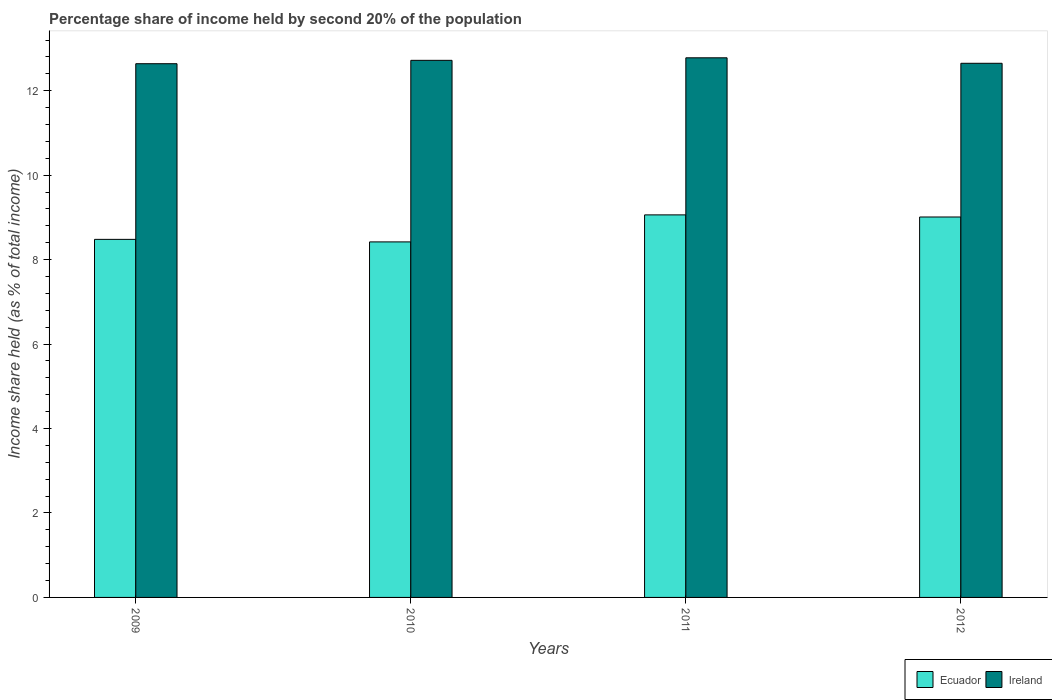How many groups of bars are there?
Provide a short and direct response. 4. Are the number of bars per tick equal to the number of legend labels?
Provide a succinct answer. Yes. How many bars are there on the 2nd tick from the left?
Your answer should be compact. 2. What is the label of the 4th group of bars from the left?
Make the answer very short. 2012. In how many cases, is the number of bars for a given year not equal to the number of legend labels?
Provide a succinct answer. 0. What is the share of income held by second 20% of the population in Ecuador in 2011?
Offer a very short reply. 9.06. Across all years, what is the maximum share of income held by second 20% of the population in Ireland?
Offer a terse response. 12.78. Across all years, what is the minimum share of income held by second 20% of the population in Ecuador?
Offer a terse response. 8.42. What is the total share of income held by second 20% of the population in Ecuador in the graph?
Make the answer very short. 34.97. What is the difference between the share of income held by second 20% of the population in Ecuador in 2010 and that in 2011?
Your answer should be compact. -0.64. What is the difference between the share of income held by second 20% of the population in Ecuador in 2010 and the share of income held by second 20% of the population in Ireland in 2009?
Provide a short and direct response. -4.22. What is the average share of income held by second 20% of the population in Ireland per year?
Your response must be concise. 12.7. In the year 2010, what is the difference between the share of income held by second 20% of the population in Ireland and share of income held by second 20% of the population in Ecuador?
Make the answer very short. 4.3. What is the ratio of the share of income held by second 20% of the population in Ireland in 2009 to that in 2011?
Your response must be concise. 0.99. Is the share of income held by second 20% of the population in Ecuador in 2010 less than that in 2012?
Offer a very short reply. Yes. Is the difference between the share of income held by second 20% of the population in Ireland in 2009 and 2010 greater than the difference between the share of income held by second 20% of the population in Ecuador in 2009 and 2010?
Provide a succinct answer. No. What is the difference between the highest and the second highest share of income held by second 20% of the population in Ecuador?
Give a very brief answer. 0.05. What is the difference between the highest and the lowest share of income held by second 20% of the population in Ireland?
Make the answer very short. 0.14. What does the 1st bar from the left in 2012 represents?
Your answer should be very brief. Ecuador. What does the 1st bar from the right in 2010 represents?
Your response must be concise. Ireland. How many bars are there?
Provide a succinct answer. 8. Where does the legend appear in the graph?
Provide a short and direct response. Bottom right. How many legend labels are there?
Offer a very short reply. 2. How are the legend labels stacked?
Make the answer very short. Horizontal. What is the title of the graph?
Provide a short and direct response. Percentage share of income held by second 20% of the population. What is the label or title of the Y-axis?
Your answer should be compact. Income share held (as % of total income). What is the Income share held (as % of total income) of Ecuador in 2009?
Provide a short and direct response. 8.48. What is the Income share held (as % of total income) of Ireland in 2009?
Give a very brief answer. 12.64. What is the Income share held (as % of total income) of Ecuador in 2010?
Your answer should be compact. 8.42. What is the Income share held (as % of total income) of Ireland in 2010?
Provide a short and direct response. 12.72. What is the Income share held (as % of total income) of Ecuador in 2011?
Your answer should be very brief. 9.06. What is the Income share held (as % of total income) of Ireland in 2011?
Provide a short and direct response. 12.78. What is the Income share held (as % of total income) of Ecuador in 2012?
Your answer should be compact. 9.01. What is the Income share held (as % of total income) of Ireland in 2012?
Your answer should be very brief. 12.65. Across all years, what is the maximum Income share held (as % of total income) in Ecuador?
Give a very brief answer. 9.06. Across all years, what is the maximum Income share held (as % of total income) in Ireland?
Your answer should be compact. 12.78. Across all years, what is the minimum Income share held (as % of total income) in Ecuador?
Give a very brief answer. 8.42. Across all years, what is the minimum Income share held (as % of total income) of Ireland?
Make the answer very short. 12.64. What is the total Income share held (as % of total income) in Ecuador in the graph?
Make the answer very short. 34.97. What is the total Income share held (as % of total income) of Ireland in the graph?
Your answer should be compact. 50.79. What is the difference between the Income share held (as % of total income) in Ecuador in 2009 and that in 2010?
Provide a succinct answer. 0.06. What is the difference between the Income share held (as % of total income) in Ireland in 2009 and that in 2010?
Give a very brief answer. -0.08. What is the difference between the Income share held (as % of total income) in Ecuador in 2009 and that in 2011?
Ensure brevity in your answer.  -0.58. What is the difference between the Income share held (as % of total income) of Ireland in 2009 and that in 2011?
Offer a terse response. -0.14. What is the difference between the Income share held (as % of total income) in Ecuador in 2009 and that in 2012?
Your response must be concise. -0.53. What is the difference between the Income share held (as % of total income) in Ireland in 2009 and that in 2012?
Offer a very short reply. -0.01. What is the difference between the Income share held (as % of total income) of Ecuador in 2010 and that in 2011?
Keep it short and to the point. -0.64. What is the difference between the Income share held (as % of total income) in Ireland in 2010 and that in 2011?
Offer a very short reply. -0.06. What is the difference between the Income share held (as % of total income) of Ecuador in 2010 and that in 2012?
Provide a short and direct response. -0.59. What is the difference between the Income share held (as % of total income) of Ireland in 2010 and that in 2012?
Your response must be concise. 0.07. What is the difference between the Income share held (as % of total income) in Ireland in 2011 and that in 2012?
Offer a very short reply. 0.13. What is the difference between the Income share held (as % of total income) in Ecuador in 2009 and the Income share held (as % of total income) in Ireland in 2010?
Give a very brief answer. -4.24. What is the difference between the Income share held (as % of total income) in Ecuador in 2009 and the Income share held (as % of total income) in Ireland in 2011?
Keep it short and to the point. -4.3. What is the difference between the Income share held (as % of total income) of Ecuador in 2009 and the Income share held (as % of total income) of Ireland in 2012?
Offer a very short reply. -4.17. What is the difference between the Income share held (as % of total income) in Ecuador in 2010 and the Income share held (as % of total income) in Ireland in 2011?
Offer a very short reply. -4.36. What is the difference between the Income share held (as % of total income) in Ecuador in 2010 and the Income share held (as % of total income) in Ireland in 2012?
Your answer should be compact. -4.23. What is the difference between the Income share held (as % of total income) in Ecuador in 2011 and the Income share held (as % of total income) in Ireland in 2012?
Provide a short and direct response. -3.59. What is the average Income share held (as % of total income) of Ecuador per year?
Make the answer very short. 8.74. What is the average Income share held (as % of total income) of Ireland per year?
Offer a terse response. 12.7. In the year 2009, what is the difference between the Income share held (as % of total income) of Ecuador and Income share held (as % of total income) of Ireland?
Provide a short and direct response. -4.16. In the year 2011, what is the difference between the Income share held (as % of total income) of Ecuador and Income share held (as % of total income) of Ireland?
Provide a succinct answer. -3.72. In the year 2012, what is the difference between the Income share held (as % of total income) in Ecuador and Income share held (as % of total income) in Ireland?
Offer a very short reply. -3.64. What is the ratio of the Income share held (as % of total income) in Ecuador in 2009 to that in 2010?
Ensure brevity in your answer.  1.01. What is the ratio of the Income share held (as % of total income) of Ireland in 2009 to that in 2010?
Your answer should be very brief. 0.99. What is the ratio of the Income share held (as % of total income) of Ecuador in 2009 to that in 2011?
Your answer should be compact. 0.94. What is the ratio of the Income share held (as % of total income) in Ecuador in 2010 to that in 2011?
Ensure brevity in your answer.  0.93. What is the ratio of the Income share held (as % of total income) in Ecuador in 2010 to that in 2012?
Offer a very short reply. 0.93. What is the ratio of the Income share held (as % of total income) of Ecuador in 2011 to that in 2012?
Your answer should be very brief. 1.01. What is the ratio of the Income share held (as % of total income) in Ireland in 2011 to that in 2012?
Ensure brevity in your answer.  1.01. What is the difference between the highest and the second highest Income share held (as % of total income) in Ireland?
Make the answer very short. 0.06. What is the difference between the highest and the lowest Income share held (as % of total income) of Ecuador?
Offer a terse response. 0.64. What is the difference between the highest and the lowest Income share held (as % of total income) in Ireland?
Give a very brief answer. 0.14. 